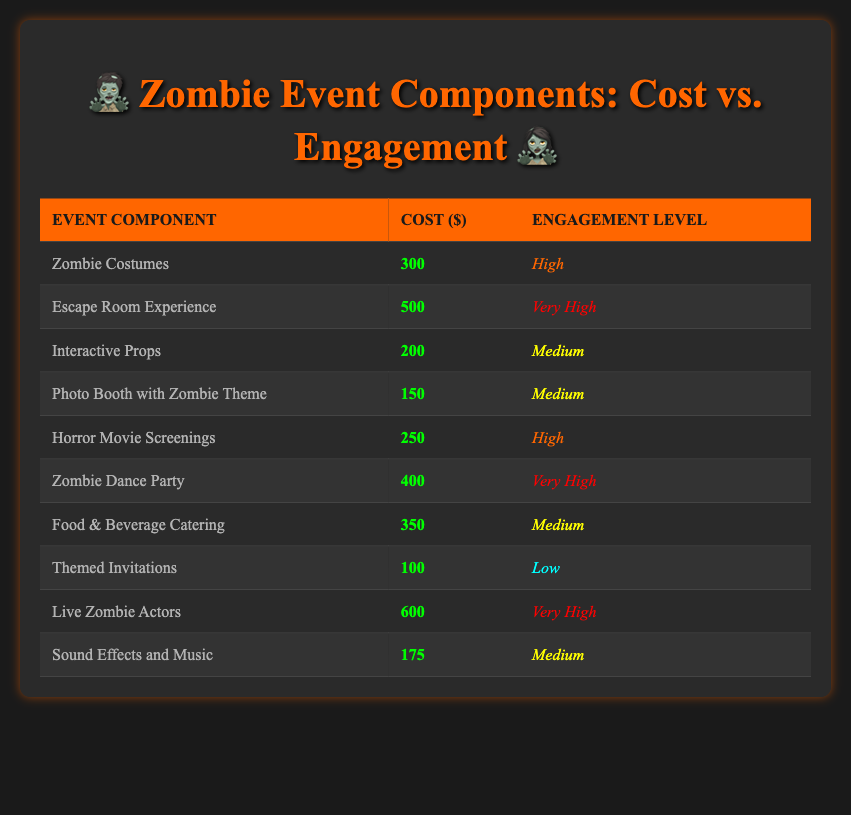What is the cost of the Zombie Dance Party? The table shows different event components along with their costs. Looking specifically at the "Zombie Dance Party" row, the cost is listed as 400.
Answer: 400 Which event component has the highest engagement level? The engagement levels are categorized in the table. By examining the "Engagement Level" column, "Live Zombie Actors," "Escape Room Experience," and "Zombie Dance Party" are all labeled as "Very High." I focused on these three entries to observe the engagement level.
Answer: Live Zombie Actors, Escape Room Experience, and Zombie Dance Party What is the total cost of components with a Medium engagement level? To answer this, I first identified the components with a "Medium" engagement level, which are "Interactive Props," "Photo Booth with Zombie Theme," "Food & Beverage Catering," and "Sound Effects and Music." Then I summed their costs: 200 + 150 + 350 + 175 = 875.
Answer: 875 Is there any component that costs less than 200? I looked through the table to see if any listed event component has a cost less than 200. The "Themed Invitations" is the only entry with a cost of 100, confirming the statement is true.
Answer: Yes What is the average cost of the components categorized as "Very High" engagement? First, I identified which components are marked as "Very High": "Escape Room Experience," "Zombie Dance Party," and "Live Zombie Actors," with costs of 500, 400, and 600, respectively. I calculated the total cost by summing these: 500 + 400 + 600 = 1500. Since there are three components, the average cost is 1500 / 3 = 500.
Answer: 500 How many event components have a cost between 150 and 300? I scanned the table to find event components that fall within the cost range of 150 to 300. These components are "Horror Movie Screenings" (250), "Zombie Costumes" (300), and the "Photo Booth with Zombie Theme" (150). This totals to three components in this range.
Answer: 3 What engagement level do event components with a cost greater than 300 predominantly share? First, I identified components that cost more than 300: "Zombie Dance Party" (400), "Live Zombie Actors" (600), and "Escape Room Experience" (500). Evaluating their engagement levels, both "Live Zombie Actors" and "Escape Room Experience" are "Very High," while "Zombie Dance Party" is also "Very High." Therefore, the predominant engagement level observed is "Very High."
Answer: Very High Which engagement level is associated with the lowest cost component? In the table, I determined the lowest cost component is "Themed Invitations," with a cost of 100. The corresponding engagement level for this component is "Low."
Answer: Low 